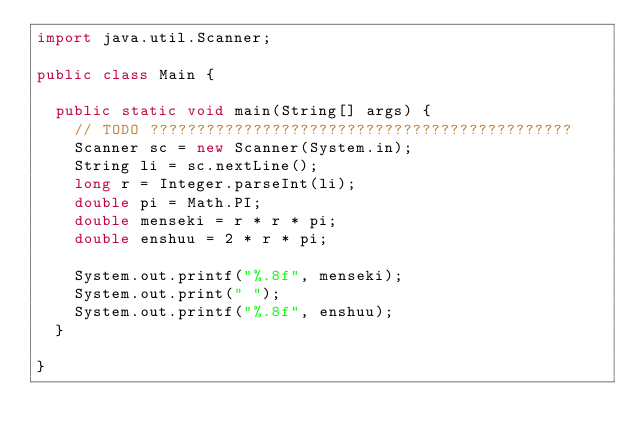<code> <loc_0><loc_0><loc_500><loc_500><_Java_>import java.util.Scanner;

public class Main {

	public static void main(String[] args) {
		// TODO ?????????????????????????????????????????????
		Scanner sc = new Scanner(System.in);
		String li = sc.nextLine();
		long r = Integer.parseInt(li);
		double pi = Math.PI;
		double menseki = r * r * pi;
		double enshuu = 2 * r * pi;

		System.out.printf("%.8f", menseki);
		System.out.print(" ");
		System.out.printf("%.8f", enshuu);
	}

}</code> 